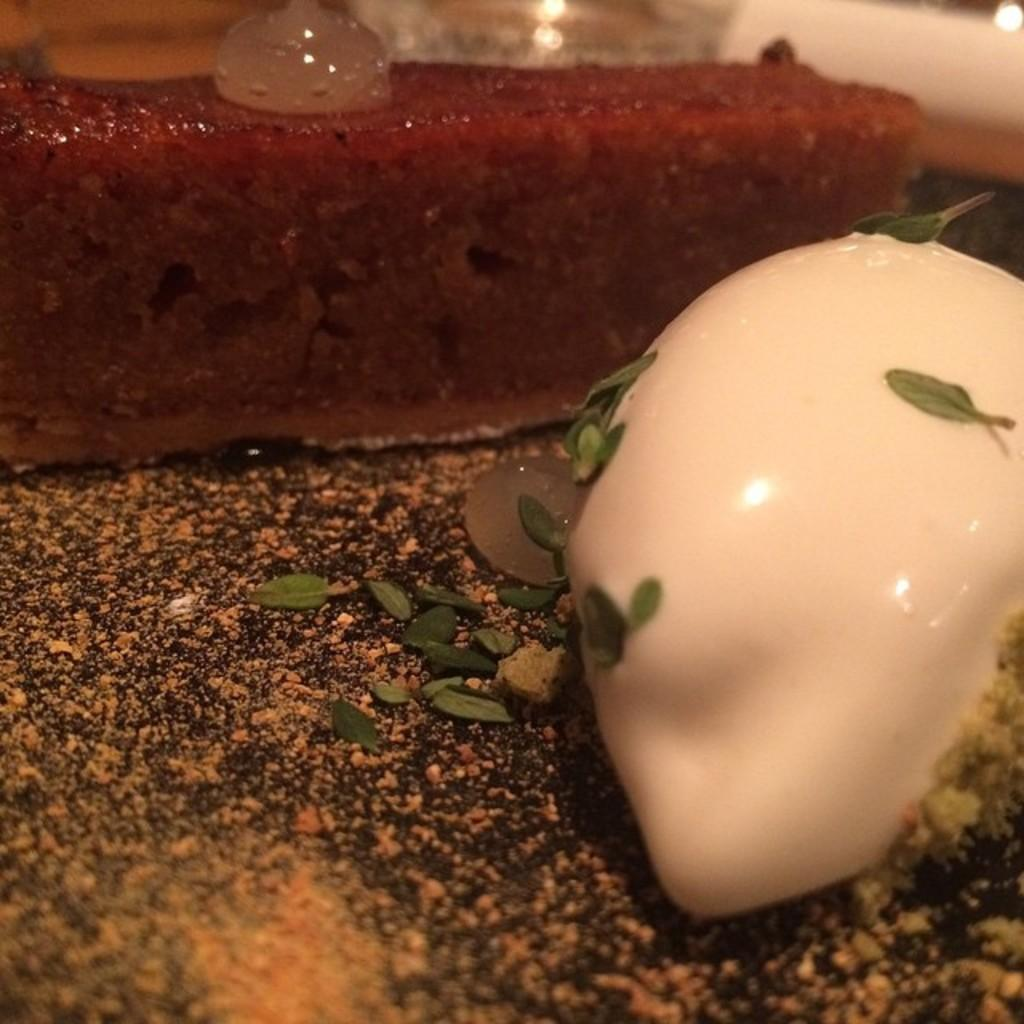What type of objects can be seen in the image? There are food items in the image. Can you see a zebra in the image? No, there is no zebra present in the image. 